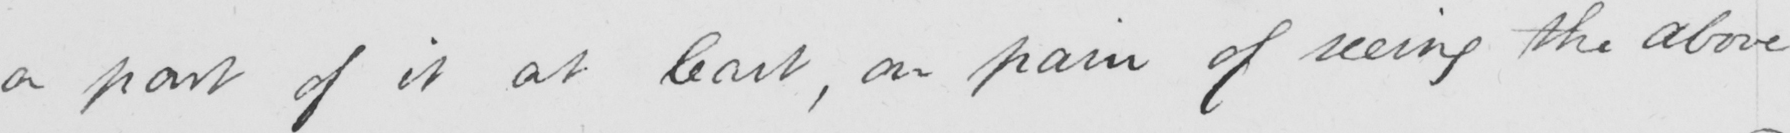Please provide the text content of this handwritten line. a part of it at least , on pain of seeing the above 